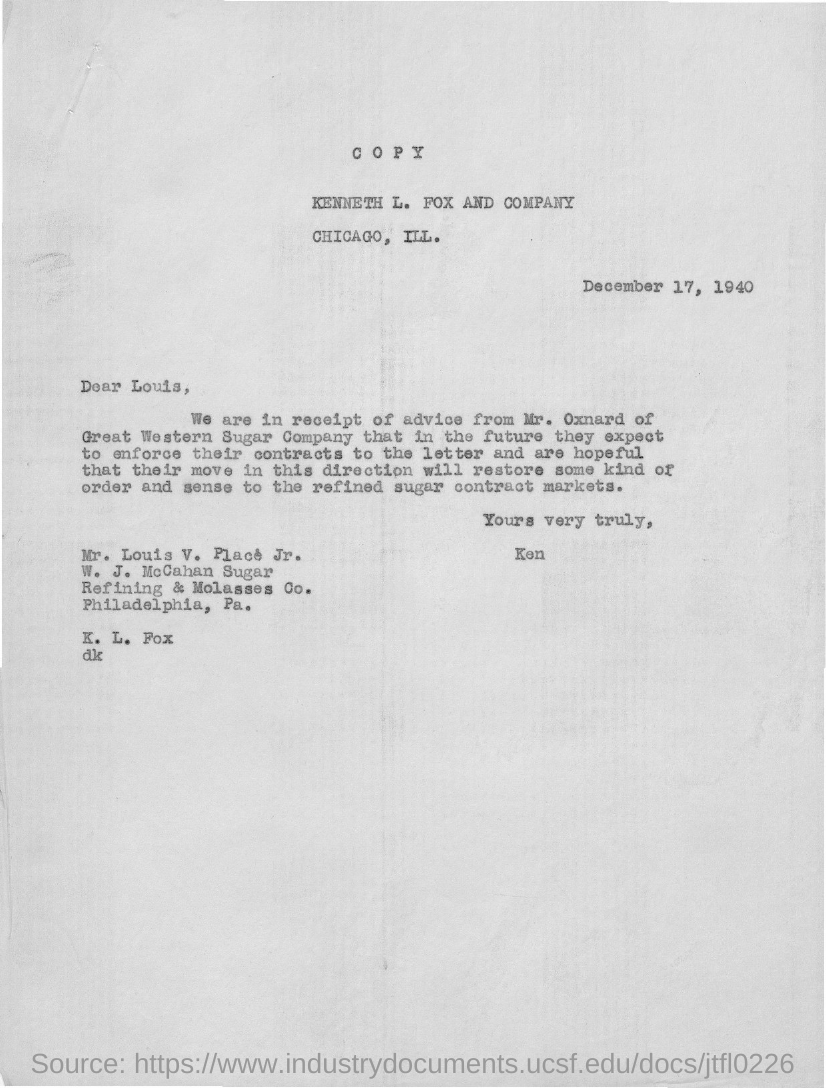Indicate a few pertinent items in this graphic. The date on the document is December 17, 1940. The letter is from Kenneth. The individuals in receipt of Mr. Oxnard's advice are uncertain. The letter is addressed to Louis V. Place Jr. 